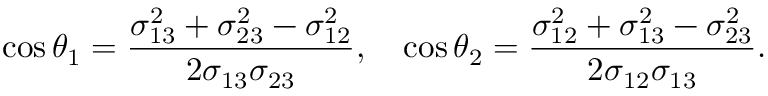Convert formula to latex. <formula><loc_0><loc_0><loc_500><loc_500>\cos \theta _ { 1 } = \frac { \sigma _ { 1 3 } ^ { 2 } + \sigma _ { 2 3 } ^ { 2 } - \sigma _ { 1 2 } ^ { 2 } } { 2 \sigma _ { 1 3 } \sigma _ { 2 3 } } , \quad \cos \theta _ { 2 } = \frac { \sigma _ { 1 2 } ^ { 2 } + \sigma _ { 1 3 } ^ { 2 } - \sigma _ { 2 3 } ^ { 2 } } { 2 \sigma _ { 1 2 } \sigma _ { 1 3 } } .</formula> 